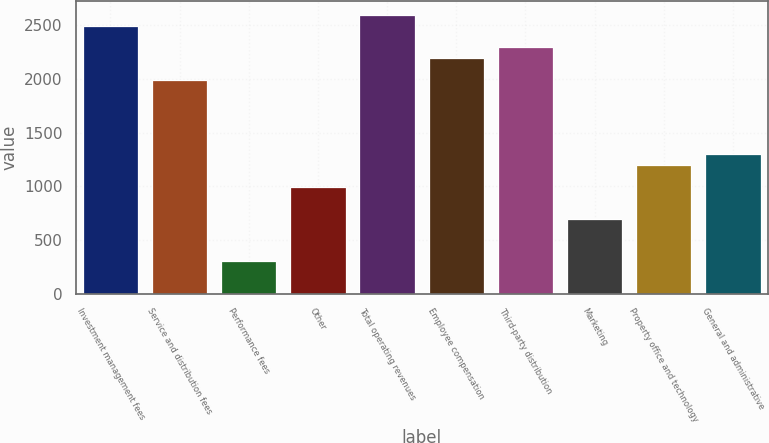Convert chart to OTSL. <chart><loc_0><loc_0><loc_500><loc_500><bar_chart><fcel>Investment management fees<fcel>Service and distribution fees<fcel>Performance fees<fcel>Other<fcel>Total operating revenues<fcel>Employee compensation<fcel>Third-party distribution<fcel>Marketing<fcel>Property office and technology<fcel>General and administrative<nl><fcel>2494.37<fcel>1995.52<fcel>299.43<fcel>997.82<fcel>2594.14<fcel>2195.06<fcel>2294.83<fcel>698.51<fcel>1197.36<fcel>1297.13<nl></chart> 